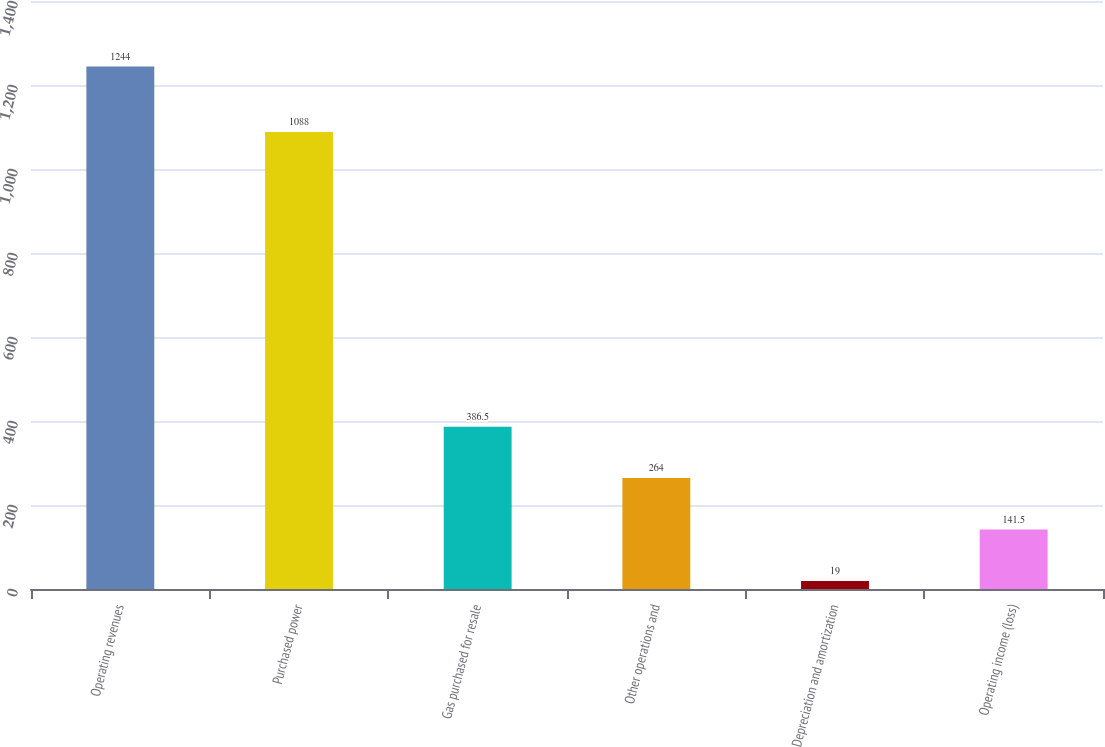Convert chart. <chart><loc_0><loc_0><loc_500><loc_500><bar_chart><fcel>Operating revenues<fcel>Purchased power<fcel>Gas purchased for resale<fcel>Other operations and<fcel>Depreciation and amortization<fcel>Operating income (loss)<nl><fcel>1244<fcel>1088<fcel>386.5<fcel>264<fcel>19<fcel>141.5<nl></chart> 